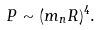<formula> <loc_0><loc_0><loc_500><loc_500>P \sim ( m _ { n } R ) ^ { 4 } .</formula> 